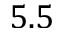Convert formula to latex. <formula><loc_0><loc_0><loc_500><loc_500>5 . 5</formula> 